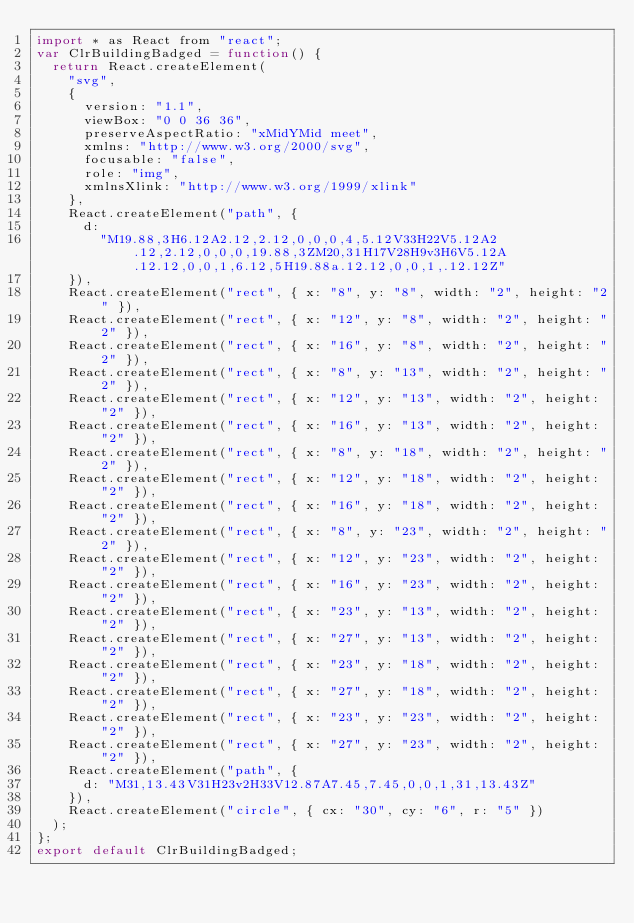<code> <loc_0><loc_0><loc_500><loc_500><_JavaScript_>import * as React from "react";
var ClrBuildingBadged = function() {
  return React.createElement(
    "svg",
    {
      version: "1.1",
      viewBox: "0 0 36 36",
      preserveAspectRatio: "xMidYMid meet",
      xmlns: "http://www.w3.org/2000/svg",
      focusable: "false",
      role: "img",
      xmlnsXlink: "http://www.w3.org/1999/xlink"
    },
    React.createElement("path", {
      d:
        "M19.88,3H6.12A2.12,2.12,0,0,0,4,5.12V33H22V5.12A2.12,2.12,0,0,0,19.88,3ZM20,31H17V28H9v3H6V5.12A.12.12,0,0,1,6.12,5H19.88a.12.12,0,0,1,.12.12Z"
    }),
    React.createElement("rect", { x: "8", y: "8", width: "2", height: "2" }),
    React.createElement("rect", { x: "12", y: "8", width: "2", height: "2" }),
    React.createElement("rect", { x: "16", y: "8", width: "2", height: "2" }),
    React.createElement("rect", { x: "8", y: "13", width: "2", height: "2" }),
    React.createElement("rect", { x: "12", y: "13", width: "2", height: "2" }),
    React.createElement("rect", { x: "16", y: "13", width: "2", height: "2" }),
    React.createElement("rect", { x: "8", y: "18", width: "2", height: "2" }),
    React.createElement("rect", { x: "12", y: "18", width: "2", height: "2" }),
    React.createElement("rect", { x: "16", y: "18", width: "2", height: "2" }),
    React.createElement("rect", { x: "8", y: "23", width: "2", height: "2" }),
    React.createElement("rect", { x: "12", y: "23", width: "2", height: "2" }),
    React.createElement("rect", { x: "16", y: "23", width: "2", height: "2" }),
    React.createElement("rect", { x: "23", y: "13", width: "2", height: "2" }),
    React.createElement("rect", { x: "27", y: "13", width: "2", height: "2" }),
    React.createElement("rect", { x: "23", y: "18", width: "2", height: "2" }),
    React.createElement("rect", { x: "27", y: "18", width: "2", height: "2" }),
    React.createElement("rect", { x: "23", y: "23", width: "2", height: "2" }),
    React.createElement("rect", { x: "27", y: "23", width: "2", height: "2" }),
    React.createElement("path", {
      d: "M31,13.43V31H23v2H33V12.87A7.45,7.45,0,0,1,31,13.43Z"
    }),
    React.createElement("circle", { cx: "30", cy: "6", r: "5" })
  );
};
export default ClrBuildingBadged;
</code> 